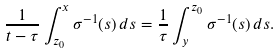Convert formula to latex. <formula><loc_0><loc_0><loc_500><loc_500>\frac { 1 } { t - \tau } \int _ { z _ { 0 } } ^ { x } \sigma ^ { - 1 } ( s ) \, d s = \frac { 1 } { \tau } \int _ { y } ^ { z _ { 0 } } \sigma ^ { - 1 } ( s ) \, d s .</formula> 